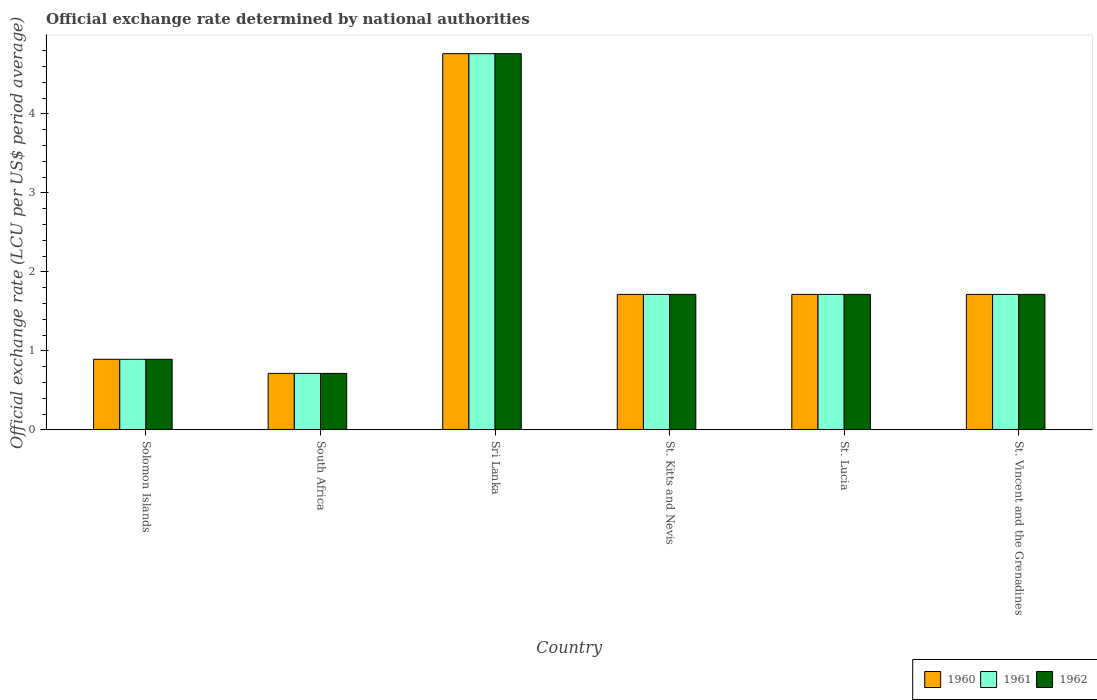How many groups of bars are there?
Ensure brevity in your answer.  6. How many bars are there on the 6th tick from the left?
Offer a terse response. 3. How many bars are there on the 2nd tick from the right?
Provide a short and direct response. 3. What is the label of the 1st group of bars from the left?
Give a very brief answer. Solomon Islands. What is the official exchange rate in 1960 in St. Lucia?
Offer a terse response. 1.71. Across all countries, what is the maximum official exchange rate in 1962?
Keep it short and to the point. 4.76. Across all countries, what is the minimum official exchange rate in 1962?
Your answer should be compact. 0.71. In which country was the official exchange rate in 1962 maximum?
Keep it short and to the point. Sri Lanka. In which country was the official exchange rate in 1960 minimum?
Your response must be concise. South Africa. What is the total official exchange rate in 1961 in the graph?
Provide a short and direct response. 11.51. What is the difference between the official exchange rate in 1961 in Solomon Islands and that in St. Kitts and Nevis?
Provide a short and direct response. -0.82. What is the difference between the official exchange rate in 1962 in Solomon Islands and the official exchange rate in 1960 in St. Vincent and the Grenadines?
Keep it short and to the point. -0.82. What is the average official exchange rate in 1961 per country?
Give a very brief answer. 1.92. In how many countries, is the official exchange rate in 1960 greater than 4.4 LCU?
Offer a terse response. 1. What is the ratio of the official exchange rate in 1960 in Solomon Islands to that in South Africa?
Give a very brief answer. 1.25. Is the official exchange rate in 1961 in St. Lucia less than that in St. Vincent and the Grenadines?
Your response must be concise. No. Is the difference between the official exchange rate in 1962 in South Africa and St. Lucia greater than the difference between the official exchange rate in 1961 in South Africa and St. Lucia?
Provide a short and direct response. No. What is the difference between the highest and the second highest official exchange rate in 1961?
Offer a terse response. -3.05. What is the difference between the highest and the lowest official exchange rate in 1960?
Ensure brevity in your answer.  4.05. In how many countries, is the official exchange rate in 1961 greater than the average official exchange rate in 1961 taken over all countries?
Provide a succinct answer. 1. Is the sum of the official exchange rate in 1961 in Solomon Islands and St. Kitts and Nevis greater than the maximum official exchange rate in 1962 across all countries?
Offer a terse response. No. What does the 3rd bar from the left in South Africa represents?
Your answer should be compact. 1962. What does the 2nd bar from the right in Solomon Islands represents?
Ensure brevity in your answer.  1961. Is it the case that in every country, the sum of the official exchange rate in 1962 and official exchange rate in 1961 is greater than the official exchange rate in 1960?
Ensure brevity in your answer.  Yes. How many bars are there?
Offer a terse response. 18. Are all the bars in the graph horizontal?
Your response must be concise. No. How many countries are there in the graph?
Offer a very short reply. 6. Does the graph contain any zero values?
Keep it short and to the point. No. Does the graph contain grids?
Your response must be concise. No. How many legend labels are there?
Make the answer very short. 3. What is the title of the graph?
Ensure brevity in your answer.  Official exchange rate determined by national authorities. Does "1960" appear as one of the legend labels in the graph?
Make the answer very short. Yes. What is the label or title of the X-axis?
Offer a terse response. Country. What is the label or title of the Y-axis?
Offer a terse response. Official exchange rate (LCU per US$ period average). What is the Official exchange rate (LCU per US$ period average) of 1960 in Solomon Islands?
Your response must be concise. 0.89. What is the Official exchange rate (LCU per US$ period average) of 1961 in Solomon Islands?
Keep it short and to the point. 0.89. What is the Official exchange rate (LCU per US$ period average) in 1962 in Solomon Islands?
Your answer should be very brief. 0.89. What is the Official exchange rate (LCU per US$ period average) in 1960 in South Africa?
Give a very brief answer. 0.71. What is the Official exchange rate (LCU per US$ period average) of 1961 in South Africa?
Your response must be concise. 0.71. What is the Official exchange rate (LCU per US$ period average) in 1962 in South Africa?
Ensure brevity in your answer.  0.71. What is the Official exchange rate (LCU per US$ period average) of 1960 in Sri Lanka?
Ensure brevity in your answer.  4.76. What is the Official exchange rate (LCU per US$ period average) of 1961 in Sri Lanka?
Ensure brevity in your answer.  4.76. What is the Official exchange rate (LCU per US$ period average) in 1962 in Sri Lanka?
Your answer should be compact. 4.76. What is the Official exchange rate (LCU per US$ period average) of 1960 in St. Kitts and Nevis?
Offer a terse response. 1.71. What is the Official exchange rate (LCU per US$ period average) of 1961 in St. Kitts and Nevis?
Offer a terse response. 1.71. What is the Official exchange rate (LCU per US$ period average) of 1962 in St. Kitts and Nevis?
Ensure brevity in your answer.  1.71. What is the Official exchange rate (LCU per US$ period average) in 1960 in St. Lucia?
Make the answer very short. 1.71. What is the Official exchange rate (LCU per US$ period average) in 1961 in St. Lucia?
Offer a very short reply. 1.71. What is the Official exchange rate (LCU per US$ period average) in 1962 in St. Lucia?
Give a very brief answer. 1.71. What is the Official exchange rate (LCU per US$ period average) in 1960 in St. Vincent and the Grenadines?
Your answer should be very brief. 1.71. What is the Official exchange rate (LCU per US$ period average) of 1961 in St. Vincent and the Grenadines?
Keep it short and to the point. 1.71. What is the Official exchange rate (LCU per US$ period average) of 1962 in St. Vincent and the Grenadines?
Give a very brief answer. 1.71. Across all countries, what is the maximum Official exchange rate (LCU per US$ period average) of 1960?
Offer a terse response. 4.76. Across all countries, what is the maximum Official exchange rate (LCU per US$ period average) of 1961?
Your answer should be compact. 4.76. Across all countries, what is the maximum Official exchange rate (LCU per US$ period average) in 1962?
Provide a succinct answer. 4.76. Across all countries, what is the minimum Official exchange rate (LCU per US$ period average) of 1960?
Ensure brevity in your answer.  0.71. Across all countries, what is the minimum Official exchange rate (LCU per US$ period average) in 1961?
Your answer should be very brief. 0.71. Across all countries, what is the minimum Official exchange rate (LCU per US$ period average) of 1962?
Offer a terse response. 0.71. What is the total Official exchange rate (LCU per US$ period average) in 1960 in the graph?
Ensure brevity in your answer.  11.51. What is the total Official exchange rate (LCU per US$ period average) of 1961 in the graph?
Provide a short and direct response. 11.51. What is the total Official exchange rate (LCU per US$ period average) of 1962 in the graph?
Give a very brief answer. 11.51. What is the difference between the Official exchange rate (LCU per US$ period average) of 1960 in Solomon Islands and that in South Africa?
Your answer should be compact. 0.18. What is the difference between the Official exchange rate (LCU per US$ period average) in 1961 in Solomon Islands and that in South Africa?
Provide a succinct answer. 0.18. What is the difference between the Official exchange rate (LCU per US$ period average) in 1962 in Solomon Islands and that in South Africa?
Provide a succinct answer. 0.18. What is the difference between the Official exchange rate (LCU per US$ period average) of 1960 in Solomon Islands and that in Sri Lanka?
Give a very brief answer. -3.87. What is the difference between the Official exchange rate (LCU per US$ period average) of 1961 in Solomon Islands and that in Sri Lanka?
Your answer should be very brief. -3.87. What is the difference between the Official exchange rate (LCU per US$ period average) in 1962 in Solomon Islands and that in Sri Lanka?
Your answer should be very brief. -3.87. What is the difference between the Official exchange rate (LCU per US$ period average) of 1960 in Solomon Islands and that in St. Kitts and Nevis?
Your response must be concise. -0.82. What is the difference between the Official exchange rate (LCU per US$ period average) in 1961 in Solomon Islands and that in St. Kitts and Nevis?
Your answer should be very brief. -0.82. What is the difference between the Official exchange rate (LCU per US$ period average) of 1962 in Solomon Islands and that in St. Kitts and Nevis?
Ensure brevity in your answer.  -0.82. What is the difference between the Official exchange rate (LCU per US$ period average) in 1960 in Solomon Islands and that in St. Lucia?
Offer a very short reply. -0.82. What is the difference between the Official exchange rate (LCU per US$ period average) of 1961 in Solomon Islands and that in St. Lucia?
Offer a terse response. -0.82. What is the difference between the Official exchange rate (LCU per US$ period average) of 1962 in Solomon Islands and that in St. Lucia?
Ensure brevity in your answer.  -0.82. What is the difference between the Official exchange rate (LCU per US$ period average) in 1960 in Solomon Islands and that in St. Vincent and the Grenadines?
Ensure brevity in your answer.  -0.82. What is the difference between the Official exchange rate (LCU per US$ period average) in 1961 in Solomon Islands and that in St. Vincent and the Grenadines?
Offer a terse response. -0.82. What is the difference between the Official exchange rate (LCU per US$ period average) of 1962 in Solomon Islands and that in St. Vincent and the Grenadines?
Provide a succinct answer. -0.82. What is the difference between the Official exchange rate (LCU per US$ period average) of 1960 in South Africa and that in Sri Lanka?
Make the answer very short. -4.05. What is the difference between the Official exchange rate (LCU per US$ period average) in 1961 in South Africa and that in Sri Lanka?
Your answer should be compact. -4.05. What is the difference between the Official exchange rate (LCU per US$ period average) of 1962 in South Africa and that in Sri Lanka?
Ensure brevity in your answer.  -4.05. What is the difference between the Official exchange rate (LCU per US$ period average) of 1961 in South Africa and that in St. Kitts and Nevis?
Offer a very short reply. -1. What is the difference between the Official exchange rate (LCU per US$ period average) of 1962 in South Africa and that in St. Kitts and Nevis?
Make the answer very short. -1. What is the difference between the Official exchange rate (LCU per US$ period average) of 1961 in South Africa and that in St. Lucia?
Give a very brief answer. -1. What is the difference between the Official exchange rate (LCU per US$ period average) of 1960 in South Africa and that in St. Vincent and the Grenadines?
Make the answer very short. -1. What is the difference between the Official exchange rate (LCU per US$ period average) of 1960 in Sri Lanka and that in St. Kitts and Nevis?
Your answer should be compact. 3.05. What is the difference between the Official exchange rate (LCU per US$ period average) in 1961 in Sri Lanka and that in St. Kitts and Nevis?
Your answer should be very brief. 3.05. What is the difference between the Official exchange rate (LCU per US$ period average) of 1962 in Sri Lanka and that in St. Kitts and Nevis?
Offer a terse response. 3.05. What is the difference between the Official exchange rate (LCU per US$ period average) of 1960 in Sri Lanka and that in St. Lucia?
Give a very brief answer. 3.05. What is the difference between the Official exchange rate (LCU per US$ period average) of 1961 in Sri Lanka and that in St. Lucia?
Your answer should be compact. 3.05. What is the difference between the Official exchange rate (LCU per US$ period average) of 1962 in Sri Lanka and that in St. Lucia?
Offer a terse response. 3.05. What is the difference between the Official exchange rate (LCU per US$ period average) in 1960 in Sri Lanka and that in St. Vincent and the Grenadines?
Provide a succinct answer. 3.05. What is the difference between the Official exchange rate (LCU per US$ period average) in 1961 in Sri Lanka and that in St. Vincent and the Grenadines?
Keep it short and to the point. 3.05. What is the difference between the Official exchange rate (LCU per US$ period average) of 1962 in Sri Lanka and that in St. Vincent and the Grenadines?
Provide a succinct answer. 3.05. What is the difference between the Official exchange rate (LCU per US$ period average) in 1962 in St. Kitts and Nevis and that in St. Lucia?
Offer a very short reply. 0. What is the difference between the Official exchange rate (LCU per US$ period average) of 1961 in St. Kitts and Nevis and that in St. Vincent and the Grenadines?
Keep it short and to the point. 0. What is the difference between the Official exchange rate (LCU per US$ period average) of 1962 in St. Kitts and Nevis and that in St. Vincent and the Grenadines?
Give a very brief answer. 0. What is the difference between the Official exchange rate (LCU per US$ period average) in 1960 in St. Lucia and that in St. Vincent and the Grenadines?
Your response must be concise. 0. What is the difference between the Official exchange rate (LCU per US$ period average) of 1962 in St. Lucia and that in St. Vincent and the Grenadines?
Ensure brevity in your answer.  0. What is the difference between the Official exchange rate (LCU per US$ period average) in 1960 in Solomon Islands and the Official exchange rate (LCU per US$ period average) in 1961 in South Africa?
Provide a short and direct response. 0.18. What is the difference between the Official exchange rate (LCU per US$ period average) of 1960 in Solomon Islands and the Official exchange rate (LCU per US$ period average) of 1962 in South Africa?
Your answer should be compact. 0.18. What is the difference between the Official exchange rate (LCU per US$ period average) in 1961 in Solomon Islands and the Official exchange rate (LCU per US$ period average) in 1962 in South Africa?
Ensure brevity in your answer.  0.18. What is the difference between the Official exchange rate (LCU per US$ period average) of 1960 in Solomon Islands and the Official exchange rate (LCU per US$ period average) of 1961 in Sri Lanka?
Offer a very short reply. -3.87. What is the difference between the Official exchange rate (LCU per US$ period average) of 1960 in Solomon Islands and the Official exchange rate (LCU per US$ period average) of 1962 in Sri Lanka?
Give a very brief answer. -3.87. What is the difference between the Official exchange rate (LCU per US$ period average) in 1961 in Solomon Islands and the Official exchange rate (LCU per US$ period average) in 1962 in Sri Lanka?
Ensure brevity in your answer.  -3.87. What is the difference between the Official exchange rate (LCU per US$ period average) of 1960 in Solomon Islands and the Official exchange rate (LCU per US$ period average) of 1961 in St. Kitts and Nevis?
Your answer should be very brief. -0.82. What is the difference between the Official exchange rate (LCU per US$ period average) of 1960 in Solomon Islands and the Official exchange rate (LCU per US$ period average) of 1962 in St. Kitts and Nevis?
Offer a very short reply. -0.82. What is the difference between the Official exchange rate (LCU per US$ period average) in 1961 in Solomon Islands and the Official exchange rate (LCU per US$ period average) in 1962 in St. Kitts and Nevis?
Ensure brevity in your answer.  -0.82. What is the difference between the Official exchange rate (LCU per US$ period average) in 1960 in Solomon Islands and the Official exchange rate (LCU per US$ period average) in 1961 in St. Lucia?
Make the answer very short. -0.82. What is the difference between the Official exchange rate (LCU per US$ period average) in 1960 in Solomon Islands and the Official exchange rate (LCU per US$ period average) in 1962 in St. Lucia?
Ensure brevity in your answer.  -0.82. What is the difference between the Official exchange rate (LCU per US$ period average) in 1961 in Solomon Islands and the Official exchange rate (LCU per US$ period average) in 1962 in St. Lucia?
Your answer should be very brief. -0.82. What is the difference between the Official exchange rate (LCU per US$ period average) in 1960 in Solomon Islands and the Official exchange rate (LCU per US$ period average) in 1961 in St. Vincent and the Grenadines?
Offer a very short reply. -0.82. What is the difference between the Official exchange rate (LCU per US$ period average) in 1960 in Solomon Islands and the Official exchange rate (LCU per US$ period average) in 1962 in St. Vincent and the Grenadines?
Your response must be concise. -0.82. What is the difference between the Official exchange rate (LCU per US$ period average) in 1961 in Solomon Islands and the Official exchange rate (LCU per US$ period average) in 1962 in St. Vincent and the Grenadines?
Your answer should be compact. -0.82. What is the difference between the Official exchange rate (LCU per US$ period average) in 1960 in South Africa and the Official exchange rate (LCU per US$ period average) in 1961 in Sri Lanka?
Your answer should be compact. -4.05. What is the difference between the Official exchange rate (LCU per US$ period average) in 1960 in South Africa and the Official exchange rate (LCU per US$ period average) in 1962 in Sri Lanka?
Provide a short and direct response. -4.05. What is the difference between the Official exchange rate (LCU per US$ period average) of 1961 in South Africa and the Official exchange rate (LCU per US$ period average) of 1962 in Sri Lanka?
Offer a terse response. -4.05. What is the difference between the Official exchange rate (LCU per US$ period average) in 1960 in South Africa and the Official exchange rate (LCU per US$ period average) in 1961 in St. Kitts and Nevis?
Keep it short and to the point. -1. What is the difference between the Official exchange rate (LCU per US$ period average) in 1961 in South Africa and the Official exchange rate (LCU per US$ period average) in 1962 in St. Kitts and Nevis?
Offer a very short reply. -1. What is the difference between the Official exchange rate (LCU per US$ period average) in 1960 in South Africa and the Official exchange rate (LCU per US$ period average) in 1961 in St. Lucia?
Your answer should be very brief. -1. What is the difference between the Official exchange rate (LCU per US$ period average) in 1960 in South Africa and the Official exchange rate (LCU per US$ period average) in 1961 in St. Vincent and the Grenadines?
Your answer should be very brief. -1. What is the difference between the Official exchange rate (LCU per US$ period average) in 1960 in South Africa and the Official exchange rate (LCU per US$ period average) in 1962 in St. Vincent and the Grenadines?
Provide a short and direct response. -1. What is the difference between the Official exchange rate (LCU per US$ period average) in 1960 in Sri Lanka and the Official exchange rate (LCU per US$ period average) in 1961 in St. Kitts and Nevis?
Provide a succinct answer. 3.05. What is the difference between the Official exchange rate (LCU per US$ period average) of 1960 in Sri Lanka and the Official exchange rate (LCU per US$ period average) of 1962 in St. Kitts and Nevis?
Offer a terse response. 3.05. What is the difference between the Official exchange rate (LCU per US$ period average) in 1961 in Sri Lanka and the Official exchange rate (LCU per US$ period average) in 1962 in St. Kitts and Nevis?
Provide a succinct answer. 3.05. What is the difference between the Official exchange rate (LCU per US$ period average) of 1960 in Sri Lanka and the Official exchange rate (LCU per US$ period average) of 1961 in St. Lucia?
Ensure brevity in your answer.  3.05. What is the difference between the Official exchange rate (LCU per US$ period average) of 1960 in Sri Lanka and the Official exchange rate (LCU per US$ period average) of 1962 in St. Lucia?
Offer a very short reply. 3.05. What is the difference between the Official exchange rate (LCU per US$ period average) of 1961 in Sri Lanka and the Official exchange rate (LCU per US$ period average) of 1962 in St. Lucia?
Your answer should be compact. 3.05. What is the difference between the Official exchange rate (LCU per US$ period average) of 1960 in Sri Lanka and the Official exchange rate (LCU per US$ period average) of 1961 in St. Vincent and the Grenadines?
Keep it short and to the point. 3.05. What is the difference between the Official exchange rate (LCU per US$ period average) of 1960 in Sri Lanka and the Official exchange rate (LCU per US$ period average) of 1962 in St. Vincent and the Grenadines?
Offer a terse response. 3.05. What is the difference between the Official exchange rate (LCU per US$ period average) of 1961 in Sri Lanka and the Official exchange rate (LCU per US$ period average) of 1962 in St. Vincent and the Grenadines?
Keep it short and to the point. 3.05. What is the difference between the Official exchange rate (LCU per US$ period average) of 1960 in St. Kitts and Nevis and the Official exchange rate (LCU per US$ period average) of 1962 in St. Vincent and the Grenadines?
Give a very brief answer. 0. What is the difference between the Official exchange rate (LCU per US$ period average) of 1960 in St. Lucia and the Official exchange rate (LCU per US$ period average) of 1962 in St. Vincent and the Grenadines?
Your answer should be compact. 0. What is the difference between the Official exchange rate (LCU per US$ period average) in 1961 in St. Lucia and the Official exchange rate (LCU per US$ period average) in 1962 in St. Vincent and the Grenadines?
Offer a very short reply. 0. What is the average Official exchange rate (LCU per US$ period average) in 1960 per country?
Ensure brevity in your answer.  1.92. What is the average Official exchange rate (LCU per US$ period average) of 1961 per country?
Offer a terse response. 1.92. What is the average Official exchange rate (LCU per US$ period average) in 1962 per country?
Provide a succinct answer. 1.92. What is the difference between the Official exchange rate (LCU per US$ period average) of 1960 and Official exchange rate (LCU per US$ period average) of 1961 in Solomon Islands?
Your response must be concise. 0. What is the difference between the Official exchange rate (LCU per US$ period average) in 1960 and Official exchange rate (LCU per US$ period average) in 1962 in Solomon Islands?
Your answer should be very brief. 0. What is the difference between the Official exchange rate (LCU per US$ period average) of 1960 and Official exchange rate (LCU per US$ period average) of 1962 in South Africa?
Keep it short and to the point. 0. What is the difference between the Official exchange rate (LCU per US$ period average) of 1961 and Official exchange rate (LCU per US$ period average) of 1962 in South Africa?
Your response must be concise. 0. What is the difference between the Official exchange rate (LCU per US$ period average) of 1960 and Official exchange rate (LCU per US$ period average) of 1961 in Sri Lanka?
Your answer should be very brief. 0. What is the difference between the Official exchange rate (LCU per US$ period average) in 1960 and Official exchange rate (LCU per US$ period average) in 1961 in St. Kitts and Nevis?
Your answer should be very brief. 0. What is the difference between the Official exchange rate (LCU per US$ period average) in 1960 and Official exchange rate (LCU per US$ period average) in 1961 in St. Lucia?
Make the answer very short. 0. What is the difference between the Official exchange rate (LCU per US$ period average) in 1960 and Official exchange rate (LCU per US$ period average) in 1962 in St. Lucia?
Your answer should be very brief. 0. What is the difference between the Official exchange rate (LCU per US$ period average) of 1961 and Official exchange rate (LCU per US$ period average) of 1962 in St. Lucia?
Your answer should be very brief. 0. What is the ratio of the Official exchange rate (LCU per US$ period average) of 1960 in Solomon Islands to that in Sri Lanka?
Keep it short and to the point. 0.19. What is the ratio of the Official exchange rate (LCU per US$ period average) in 1961 in Solomon Islands to that in Sri Lanka?
Give a very brief answer. 0.19. What is the ratio of the Official exchange rate (LCU per US$ period average) in 1962 in Solomon Islands to that in Sri Lanka?
Offer a very short reply. 0.19. What is the ratio of the Official exchange rate (LCU per US$ period average) in 1960 in Solomon Islands to that in St. Kitts and Nevis?
Offer a terse response. 0.52. What is the ratio of the Official exchange rate (LCU per US$ period average) in 1961 in Solomon Islands to that in St. Kitts and Nevis?
Offer a very short reply. 0.52. What is the ratio of the Official exchange rate (LCU per US$ period average) in 1962 in Solomon Islands to that in St. Kitts and Nevis?
Keep it short and to the point. 0.52. What is the ratio of the Official exchange rate (LCU per US$ period average) of 1960 in Solomon Islands to that in St. Lucia?
Provide a succinct answer. 0.52. What is the ratio of the Official exchange rate (LCU per US$ period average) of 1961 in Solomon Islands to that in St. Lucia?
Provide a short and direct response. 0.52. What is the ratio of the Official exchange rate (LCU per US$ period average) in 1962 in Solomon Islands to that in St. Lucia?
Make the answer very short. 0.52. What is the ratio of the Official exchange rate (LCU per US$ period average) of 1960 in Solomon Islands to that in St. Vincent and the Grenadines?
Offer a terse response. 0.52. What is the ratio of the Official exchange rate (LCU per US$ period average) of 1961 in Solomon Islands to that in St. Vincent and the Grenadines?
Make the answer very short. 0.52. What is the ratio of the Official exchange rate (LCU per US$ period average) in 1962 in Solomon Islands to that in St. Vincent and the Grenadines?
Ensure brevity in your answer.  0.52. What is the ratio of the Official exchange rate (LCU per US$ period average) of 1961 in South Africa to that in Sri Lanka?
Offer a terse response. 0.15. What is the ratio of the Official exchange rate (LCU per US$ period average) of 1960 in South Africa to that in St. Kitts and Nevis?
Your answer should be compact. 0.42. What is the ratio of the Official exchange rate (LCU per US$ period average) of 1961 in South Africa to that in St. Kitts and Nevis?
Give a very brief answer. 0.42. What is the ratio of the Official exchange rate (LCU per US$ period average) in 1962 in South Africa to that in St. Kitts and Nevis?
Your response must be concise. 0.42. What is the ratio of the Official exchange rate (LCU per US$ period average) of 1960 in South Africa to that in St. Lucia?
Your answer should be very brief. 0.42. What is the ratio of the Official exchange rate (LCU per US$ period average) in 1961 in South Africa to that in St. Lucia?
Your answer should be compact. 0.42. What is the ratio of the Official exchange rate (LCU per US$ period average) in 1962 in South Africa to that in St. Lucia?
Your response must be concise. 0.42. What is the ratio of the Official exchange rate (LCU per US$ period average) of 1960 in South Africa to that in St. Vincent and the Grenadines?
Keep it short and to the point. 0.42. What is the ratio of the Official exchange rate (LCU per US$ period average) in 1961 in South Africa to that in St. Vincent and the Grenadines?
Give a very brief answer. 0.42. What is the ratio of the Official exchange rate (LCU per US$ period average) in 1962 in South Africa to that in St. Vincent and the Grenadines?
Your answer should be compact. 0.42. What is the ratio of the Official exchange rate (LCU per US$ period average) of 1960 in Sri Lanka to that in St. Kitts and Nevis?
Your response must be concise. 2.78. What is the ratio of the Official exchange rate (LCU per US$ period average) of 1961 in Sri Lanka to that in St. Kitts and Nevis?
Your answer should be compact. 2.78. What is the ratio of the Official exchange rate (LCU per US$ period average) of 1962 in Sri Lanka to that in St. Kitts and Nevis?
Your answer should be very brief. 2.78. What is the ratio of the Official exchange rate (LCU per US$ period average) in 1960 in Sri Lanka to that in St. Lucia?
Your answer should be very brief. 2.78. What is the ratio of the Official exchange rate (LCU per US$ period average) of 1961 in Sri Lanka to that in St. Lucia?
Your response must be concise. 2.78. What is the ratio of the Official exchange rate (LCU per US$ period average) of 1962 in Sri Lanka to that in St. Lucia?
Your answer should be compact. 2.78. What is the ratio of the Official exchange rate (LCU per US$ period average) of 1960 in Sri Lanka to that in St. Vincent and the Grenadines?
Provide a short and direct response. 2.78. What is the ratio of the Official exchange rate (LCU per US$ period average) of 1961 in Sri Lanka to that in St. Vincent and the Grenadines?
Provide a succinct answer. 2.78. What is the ratio of the Official exchange rate (LCU per US$ period average) in 1962 in Sri Lanka to that in St. Vincent and the Grenadines?
Offer a terse response. 2.78. What is the ratio of the Official exchange rate (LCU per US$ period average) in 1961 in St. Kitts and Nevis to that in St. Lucia?
Give a very brief answer. 1. What is the ratio of the Official exchange rate (LCU per US$ period average) of 1960 in St. Kitts and Nevis to that in St. Vincent and the Grenadines?
Make the answer very short. 1. What is the ratio of the Official exchange rate (LCU per US$ period average) in 1961 in St. Kitts and Nevis to that in St. Vincent and the Grenadines?
Your response must be concise. 1. What is the ratio of the Official exchange rate (LCU per US$ period average) in 1961 in St. Lucia to that in St. Vincent and the Grenadines?
Your answer should be very brief. 1. What is the difference between the highest and the second highest Official exchange rate (LCU per US$ period average) in 1960?
Your answer should be very brief. 3.05. What is the difference between the highest and the second highest Official exchange rate (LCU per US$ period average) of 1961?
Your answer should be compact. 3.05. What is the difference between the highest and the second highest Official exchange rate (LCU per US$ period average) of 1962?
Ensure brevity in your answer.  3.05. What is the difference between the highest and the lowest Official exchange rate (LCU per US$ period average) in 1960?
Your response must be concise. 4.05. What is the difference between the highest and the lowest Official exchange rate (LCU per US$ period average) in 1961?
Ensure brevity in your answer.  4.05. What is the difference between the highest and the lowest Official exchange rate (LCU per US$ period average) in 1962?
Provide a short and direct response. 4.05. 